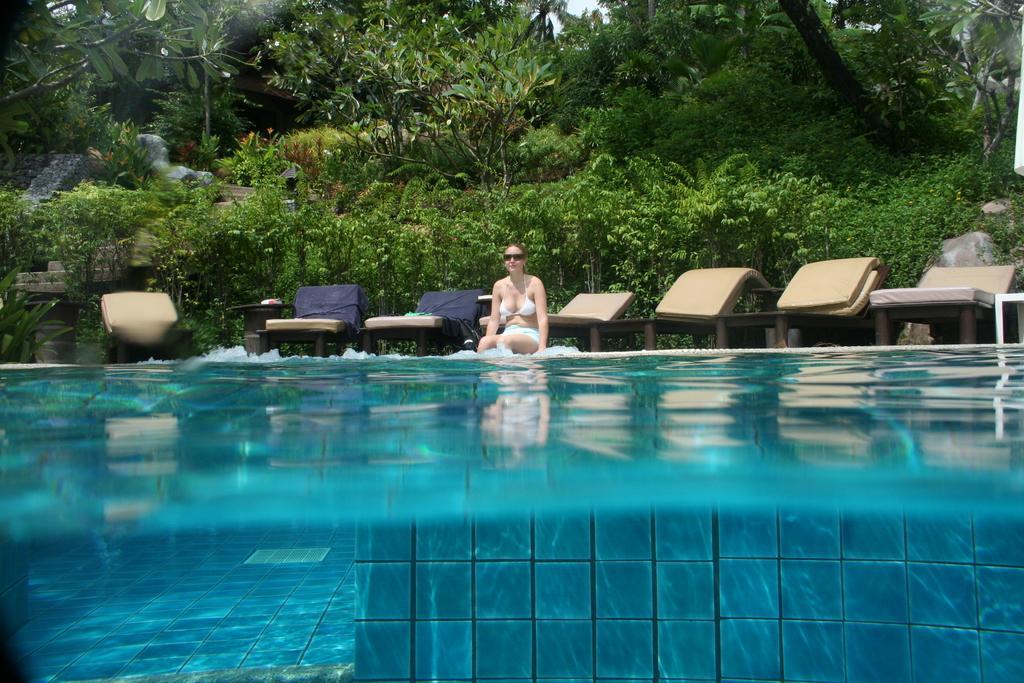In one or two sentences, can you explain what this image depicts? In this image there is one swimming pool at bottom of this image and there are some resting beds in middle of this image and there is one person sitting in middle of this image and there are some trees in the background. 